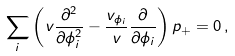Convert formula to latex. <formula><loc_0><loc_0><loc_500><loc_500>\sum _ { i } \left ( v \frac { \partial ^ { 2 } } { \partial \phi _ { i } ^ { 2 } } - \frac { v _ { \phi _ { i } } } { v } \frac { \partial } { \partial \phi _ { i } } \right ) p _ { + } = 0 \, ,</formula> 